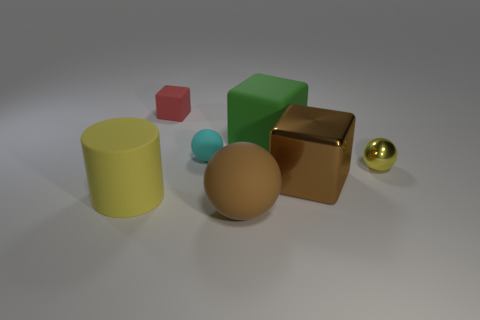How many other objects are there of the same color as the big matte cube?
Keep it short and to the point. 0. What number of small cyan objects are the same material as the tiny yellow object?
Offer a terse response. 0. The large cube that is made of the same material as the big yellow cylinder is what color?
Provide a short and direct response. Green. Does the object on the right side of the brown metallic block have the same size as the large ball?
Offer a very short reply. No. What is the color of the big rubber thing that is the same shape as the small metallic thing?
Keep it short and to the point. Brown. What is the shape of the large brown thing that is behind the large matte thing on the left side of the small matte thing that is on the left side of the small matte ball?
Offer a terse response. Cube. Is the shape of the small red object the same as the big green matte object?
Give a very brief answer. Yes. The large matte object that is in front of the large object on the left side of the small cyan ball is what shape?
Provide a succinct answer. Sphere. Are there any purple blocks?
Your response must be concise. No. How many brown rubber things are to the left of the rubber block left of the small ball that is to the left of the green cube?
Make the answer very short. 0. 